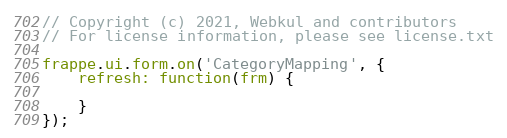<code> <loc_0><loc_0><loc_500><loc_500><_JavaScript_>// Copyright (c) 2021, Webkul and contributors
// For license information, please see license.txt

frappe.ui.form.on('CategoryMapping', {
	refresh: function(frm) {

	}
});
</code> 